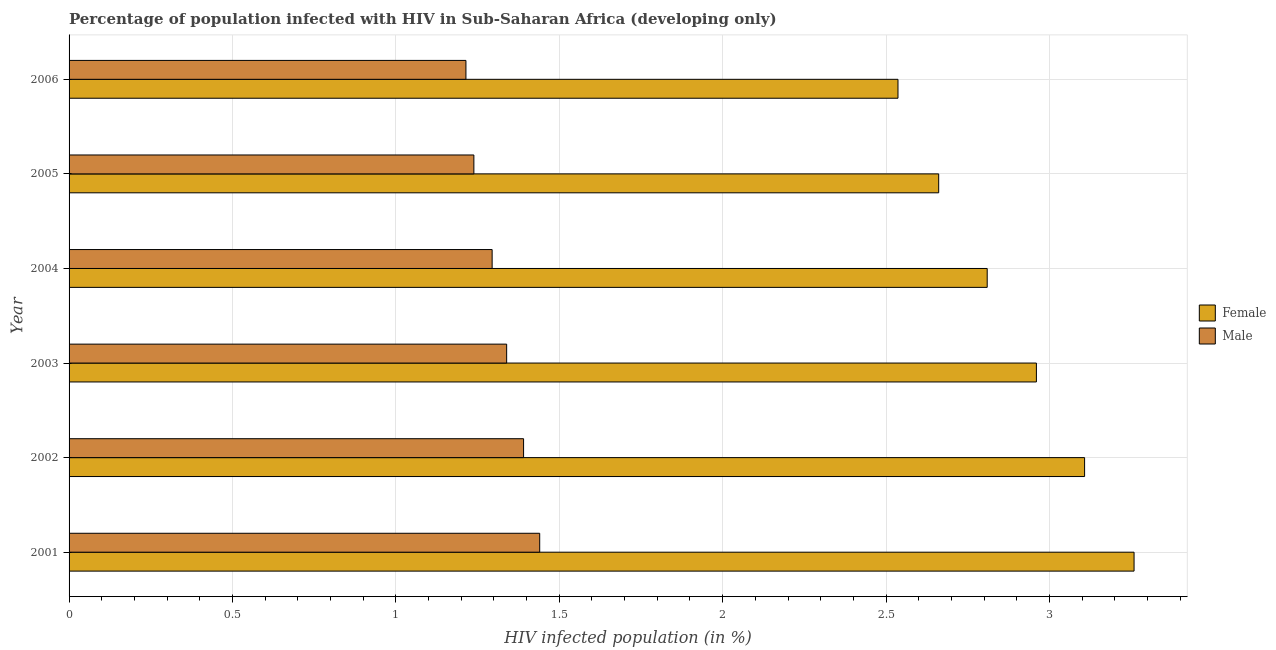How many different coloured bars are there?
Offer a very short reply. 2. Are the number of bars per tick equal to the number of legend labels?
Ensure brevity in your answer.  Yes. How many bars are there on the 1st tick from the bottom?
Provide a succinct answer. 2. What is the label of the 5th group of bars from the top?
Keep it short and to the point. 2002. In how many cases, is the number of bars for a given year not equal to the number of legend labels?
Provide a short and direct response. 0. What is the percentage of males who are infected with hiv in 2001?
Make the answer very short. 1.44. Across all years, what is the maximum percentage of males who are infected with hiv?
Ensure brevity in your answer.  1.44. Across all years, what is the minimum percentage of females who are infected with hiv?
Ensure brevity in your answer.  2.54. In which year was the percentage of females who are infected with hiv maximum?
Provide a succinct answer. 2001. In which year was the percentage of males who are infected with hiv minimum?
Offer a terse response. 2006. What is the total percentage of females who are infected with hiv in the graph?
Your response must be concise. 17.33. What is the difference between the percentage of males who are infected with hiv in 2001 and that in 2004?
Provide a short and direct response. 0.15. What is the difference between the percentage of males who are infected with hiv in 2002 and the percentage of females who are infected with hiv in 2001?
Provide a succinct answer. -1.87. What is the average percentage of males who are infected with hiv per year?
Offer a terse response. 1.32. In the year 2001, what is the difference between the percentage of females who are infected with hiv and percentage of males who are infected with hiv?
Ensure brevity in your answer.  1.82. What is the ratio of the percentage of males who are infected with hiv in 2001 to that in 2006?
Your answer should be compact. 1.19. Is the percentage of males who are infected with hiv in 2002 less than that in 2004?
Give a very brief answer. No. What is the difference between the highest and the second highest percentage of males who are infected with hiv?
Offer a terse response. 0.05. What is the difference between the highest and the lowest percentage of males who are infected with hiv?
Offer a terse response. 0.23. Are all the bars in the graph horizontal?
Give a very brief answer. Yes. What is the difference between two consecutive major ticks on the X-axis?
Offer a very short reply. 0.5. Where does the legend appear in the graph?
Offer a very short reply. Center right. What is the title of the graph?
Offer a very short reply. Percentage of population infected with HIV in Sub-Saharan Africa (developing only). What is the label or title of the X-axis?
Your response must be concise. HIV infected population (in %). What is the HIV infected population (in %) in Female in 2001?
Your answer should be very brief. 3.26. What is the HIV infected population (in %) of Male in 2001?
Offer a very short reply. 1.44. What is the HIV infected population (in %) in Female in 2002?
Keep it short and to the point. 3.11. What is the HIV infected population (in %) in Male in 2002?
Your answer should be very brief. 1.39. What is the HIV infected population (in %) in Female in 2003?
Your answer should be very brief. 2.96. What is the HIV infected population (in %) in Male in 2003?
Your answer should be compact. 1.34. What is the HIV infected population (in %) of Female in 2004?
Ensure brevity in your answer.  2.81. What is the HIV infected population (in %) of Male in 2004?
Offer a very short reply. 1.29. What is the HIV infected population (in %) in Female in 2005?
Your answer should be very brief. 2.66. What is the HIV infected population (in %) of Male in 2005?
Your answer should be very brief. 1.24. What is the HIV infected population (in %) of Female in 2006?
Provide a succinct answer. 2.54. What is the HIV infected population (in %) in Male in 2006?
Give a very brief answer. 1.21. Across all years, what is the maximum HIV infected population (in %) in Female?
Keep it short and to the point. 3.26. Across all years, what is the maximum HIV infected population (in %) in Male?
Keep it short and to the point. 1.44. Across all years, what is the minimum HIV infected population (in %) of Female?
Ensure brevity in your answer.  2.54. Across all years, what is the minimum HIV infected population (in %) of Male?
Provide a succinct answer. 1.21. What is the total HIV infected population (in %) in Female in the graph?
Offer a very short reply. 17.33. What is the total HIV infected population (in %) in Male in the graph?
Your answer should be compact. 7.92. What is the difference between the HIV infected population (in %) in Female in 2001 and that in 2002?
Your response must be concise. 0.15. What is the difference between the HIV infected population (in %) of Male in 2001 and that in 2002?
Keep it short and to the point. 0.05. What is the difference between the HIV infected population (in %) of Female in 2001 and that in 2003?
Offer a terse response. 0.3. What is the difference between the HIV infected population (in %) in Male in 2001 and that in 2003?
Provide a short and direct response. 0.1. What is the difference between the HIV infected population (in %) of Female in 2001 and that in 2004?
Your response must be concise. 0.45. What is the difference between the HIV infected population (in %) of Male in 2001 and that in 2004?
Make the answer very short. 0.15. What is the difference between the HIV infected population (in %) of Female in 2001 and that in 2005?
Your response must be concise. 0.6. What is the difference between the HIV infected population (in %) in Male in 2001 and that in 2005?
Offer a terse response. 0.2. What is the difference between the HIV infected population (in %) of Female in 2001 and that in 2006?
Make the answer very short. 0.72. What is the difference between the HIV infected population (in %) of Male in 2001 and that in 2006?
Give a very brief answer. 0.23. What is the difference between the HIV infected population (in %) in Female in 2002 and that in 2003?
Give a very brief answer. 0.15. What is the difference between the HIV infected population (in %) in Male in 2002 and that in 2003?
Keep it short and to the point. 0.05. What is the difference between the HIV infected population (in %) of Female in 2002 and that in 2004?
Give a very brief answer. 0.3. What is the difference between the HIV infected population (in %) of Male in 2002 and that in 2004?
Offer a terse response. 0.1. What is the difference between the HIV infected population (in %) in Female in 2002 and that in 2005?
Offer a very short reply. 0.45. What is the difference between the HIV infected population (in %) in Male in 2002 and that in 2005?
Keep it short and to the point. 0.15. What is the difference between the HIV infected population (in %) in Female in 2002 and that in 2006?
Offer a terse response. 0.57. What is the difference between the HIV infected population (in %) of Male in 2002 and that in 2006?
Offer a very short reply. 0.18. What is the difference between the HIV infected population (in %) of Female in 2003 and that in 2004?
Provide a short and direct response. 0.15. What is the difference between the HIV infected population (in %) of Male in 2003 and that in 2004?
Your answer should be compact. 0.04. What is the difference between the HIV infected population (in %) of Female in 2003 and that in 2005?
Provide a succinct answer. 0.3. What is the difference between the HIV infected population (in %) in Male in 2003 and that in 2005?
Make the answer very short. 0.1. What is the difference between the HIV infected population (in %) in Female in 2003 and that in 2006?
Offer a terse response. 0.42. What is the difference between the HIV infected population (in %) of Male in 2003 and that in 2006?
Your response must be concise. 0.12. What is the difference between the HIV infected population (in %) in Female in 2004 and that in 2005?
Keep it short and to the point. 0.15. What is the difference between the HIV infected population (in %) of Male in 2004 and that in 2005?
Make the answer very short. 0.06. What is the difference between the HIV infected population (in %) of Female in 2004 and that in 2006?
Your answer should be very brief. 0.27. What is the difference between the HIV infected population (in %) in Male in 2004 and that in 2006?
Keep it short and to the point. 0.08. What is the difference between the HIV infected population (in %) in Female in 2005 and that in 2006?
Give a very brief answer. 0.12. What is the difference between the HIV infected population (in %) in Male in 2005 and that in 2006?
Give a very brief answer. 0.02. What is the difference between the HIV infected population (in %) of Female in 2001 and the HIV infected population (in %) of Male in 2002?
Provide a succinct answer. 1.87. What is the difference between the HIV infected population (in %) of Female in 2001 and the HIV infected population (in %) of Male in 2003?
Offer a terse response. 1.92. What is the difference between the HIV infected population (in %) of Female in 2001 and the HIV infected population (in %) of Male in 2004?
Keep it short and to the point. 1.96. What is the difference between the HIV infected population (in %) in Female in 2001 and the HIV infected population (in %) in Male in 2005?
Offer a very short reply. 2.02. What is the difference between the HIV infected population (in %) in Female in 2001 and the HIV infected population (in %) in Male in 2006?
Your answer should be compact. 2.04. What is the difference between the HIV infected population (in %) of Female in 2002 and the HIV infected population (in %) of Male in 2003?
Your answer should be compact. 1.77. What is the difference between the HIV infected population (in %) of Female in 2002 and the HIV infected population (in %) of Male in 2004?
Give a very brief answer. 1.81. What is the difference between the HIV infected population (in %) of Female in 2002 and the HIV infected population (in %) of Male in 2005?
Your answer should be very brief. 1.87. What is the difference between the HIV infected population (in %) of Female in 2002 and the HIV infected population (in %) of Male in 2006?
Provide a succinct answer. 1.89. What is the difference between the HIV infected population (in %) in Female in 2003 and the HIV infected population (in %) in Male in 2004?
Provide a succinct answer. 1.67. What is the difference between the HIV infected population (in %) in Female in 2003 and the HIV infected population (in %) in Male in 2005?
Provide a succinct answer. 1.72. What is the difference between the HIV infected population (in %) in Female in 2003 and the HIV infected population (in %) in Male in 2006?
Provide a short and direct response. 1.75. What is the difference between the HIV infected population (in %) in Female in 2004 and the HIV infected population (in %) in Male in 2005?
Provide a short and direct response. 1.57. What is the difference between the HIV infected population (in %) in Female in 2004 and the HIV infected population (in %) in Male in 2006?
Ensure brevity in your answer.  1.6. What is the difference between the HIV infected population (in %) in Female in 2005 and the HIV infected population (in %) in Male in 2006?
Provide a short and direct response. 1.45. What is the average HIV infected population (in %) in Female per year?
Make the answer very short. 2.89. What is the average HIV infected population (in %) in Male per year?
Provide a succinct answer. 1.32. In the year 2001, what is the difference between the HIV infected population (in %) in Female and HIV infected population (in %) in Male?
Provide a short and direct response. 1.82. In the year 2002, what is the difference between the HIV infected population (in %) of Female and HIV infected population (in %) of Male?
Ensure brevity in your answer.  1.72. In the year 2003, what is the difference between the HIV infected population (in %) in Female and HIV infected population (in %) in Male?
Your answer should be very brief. 1.62. In the year 2004, what is the difference between the HIV infected population (in %) of Female and HIV infected population (in %) of Male?
Your response must be concise. 1.51. In the year 2005, what is the difference between the HIV infected population (in %) in Female and HIV infected population (in %) in Male?
Provide a short and direct response. 1.42. In the year 2006, what is the difference between the HIV infected population (in %) in Female and HIV infected population (in %) in Male?
Your response must be concise. 1.32. What is the ratio of the HIV infected population (in %) in Female in 2001 to that in 2002?
Offer a very short reply. 1.05. What is the ratio of the HIV infected population (in %) in Male in 2001 to that in 2002?
Your response must be concise. 1.04. What is the ratio of the HIV infected population (in %) of Female in 2001 to that in 2003?
Keep it short and to the point. 1.1. What is the ratio of the HIV infected population (in %) in Male in 2001 to that in 2003?
Your answer should be compact. 1.08. What is the ratio of the HIV infected population (in %) in Female in 2001 to that in 2004?
Your answer should be very brief. 1.16. What is the ratio of the HIV infected population (in %) in Male in 2001 to that in 2004?
Ensure brevity in your answer.  1.11. What is the ratio of the HIV infected population (in %) in Female in 2001 to that in 2005?
Your answer should be very brief. 1.22. What is the ratio of the HIV infected population (in %) of Male in 2001 to that in 2005?
Ensure brevity in your answer.  1.16. What is the ratio of the HIV infected population (in %) in Female in 2001 to that in 2006?
Offer a terse response. 1.28. What is the ratio of the HIV infected population (in %) in Male in 2001 to that in 2006?
Provide a succinct answer. 1.19. What is the ratio of the HIV infected population (in %) of Female in 2002 to that in 2003?
Keep it short and to the point. 1.05. What is the ratio of the HIV infected population (in %) of Male in 2002 to that in 2003?
Your response must be concise. 1.04. What is the ratio of the HIV infected population (in %) in Female in 2002 to that in 2004?
Your answer should be very brief. 1.11. What is the ratio of the HIV infected population (in %) of Male in 2002 to that in 2004?
Offer a very short reply. 1.07. What is the ratio of the HIV infected population (in %) of Female in 2002 to that in 2005?
Provide a short and direct response. 1.17. What is the ratio of the HIV infected population (in %) in Male in 2002 to that in 2005?
Give a very brief answer. 1.12. What is the ratio of the HIV infected population (in %) in Female in 2002 to that in 2006?
Make the answer very short. 1.23. What is the ratio of the HIV infected population (in %) of Male in 2002 to that in 2006?
Your answer should be compact. 1.15. What is the ratio of the HIV infected population (in %) in Female in 2003 to that in 2004?
Offer a terse response. 1.05. What is the ratio of the HIV infected population (in %) in Male in 2003 to that in 2004?
Make the answer very short. 1.03. What is the ratio of the HIV infected population (in %) of Female in 2003 to that in 2005?
Provide a short and direct response. 1.11. What is the ratio of the HIV infected population (in %) of Male in 2003 to that in 2005?
Ensure brevity in your answer.  1.08. What is the ratio of the HIV infected population (in %) in Female in 2003 to that in 2006?
Ensure brevity in your answer.  1.17. What is the ratio of the HIV infected population (in %) of Male in 2003 to that in 2006?
Give a very brief answer. 1.1. What is the ratio of the HIV infected population (in %) of Female in 2004 to that in 2005?
Make the answer very short. 1.06. What is the ratio of the HIV infected population (in %) of Male in 2004 to that in 2005?
Provide a short and direct response. 1.05. What is the ratio of the HIV infected population (in %) of Female in 2004 to that in 2006?
Keep it short and to the point. 1.11. What is the ratio of the HIV infected population (in %) in Male in 2004 to that in 2006?
Ensure brevity in your answer.  1.07. What is the ratio of the HIV infected population (in %) in Female in 2005 to that in 2006?
Make the answer very short. 1.05. What is the ratio of the HIV infected population (in %) in Male in 2005 to that in 2006?
Keep it short and to the point. 1.02. What is the difference between the highest and the second highest HIV infected population (in %) of Female?
Your answer should be compact. 0.15. What is the difference between the highest and the second highest HIV infected population (in %) of Male?
Provide a succinct answer. 0.05. What is the difference between the highest and the lowest HIV infected population (in %) of Female?
Your answer should be very brief. 0.72. What is the difference between the highest and the lowest HIV infected population (in %) of Male?
Provide a succinct answer. 0.23. 